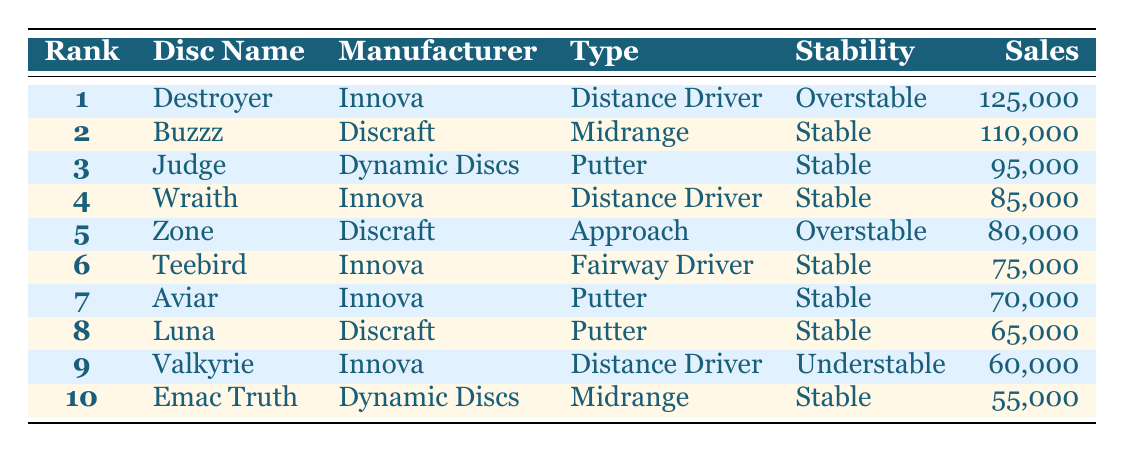What is the bestselling disc golf disc of the past year? The table shows that the disc with the highest sales is the "Destroyer" from Innova, with 125,000 sales.
Answer: Destroyer Which manufacturer has the most discs in the top 10? There are four discs manufactured by Innova (Destroyer, Wraith, Teebird, Aviar) and three by Discraft (Buzzz, Zone, Luna). Since Innova has more than any other manufacturer, the answer is Innova.
Answer: Innova What is the total sales of all discs listed in the table? To calculate total sales, add up all the sales: 125,000 + 110,000 + 95,000 + 85,000 + 80,000 + 75,000 + 70,000 + 65,000 + 60,000 + 55,000 = 1,055,000.
Answer: 1,055,000 Is the "Luna" considered an overstable disc? The table indicates that the "Luna" by Discraft is classified as a stable type, not overstable. Therefore, the statement is false.
Answer: No What type of disc is the "Judge"? According to the table, the "Judge" from Dynamic Discs is categorized as a Putter.
Answer: Putter Which disc has the lowest sales and what is its sales figure? The table shows that the disc with the lowest sales is "Emac Truth" by Dynamic Discs, with sales of 55,000.
Answer: Emac Truth, 55,000 What is the average sales within the putter category? In the table, the two putters are "Judge" (95,000) and "Aviar" (70,000). Calculate the average by summing these sales: 95,000 + 70,000 = 165,000, then divide by 2, giving 165,000 / 2 = 82,500.
Answer: 82,500 How many discs are classified as 'Overstable'? The table displays three discs classified as overstable: "Destroyer," "Zone," and "Valkyrie." Therefore, the total is three.
Answer: 3 Which disc has higher sales: "Wraith" or "Zone"? The sales figures are 85,000 for "Wraith" and 80,000 for "Zone." Since 85,000 is greater than 80,000, "Wraith" has higher sales.
Answer: Wraith 